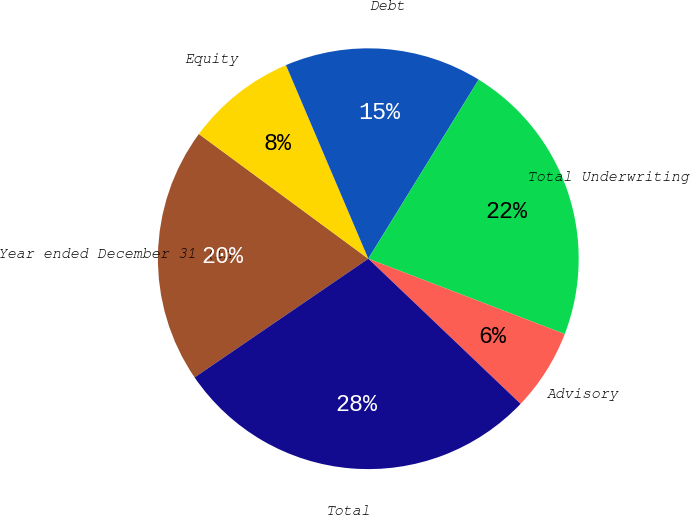Convert chart. <chart><loc_0><loc_0><loc_500><loc_500><pie_chart><fcel>Year ended December 31 (in<fcel>Equity<fcel>Debt<fcel>Total Underwriting<fcel>Advisory<fcel>Total<nl><fcel>19.64%<fcel>8.5%<fcel>15.19%<fcel>22.04%<fcel>6.29%<fcel>28.34%<nl></chart> 